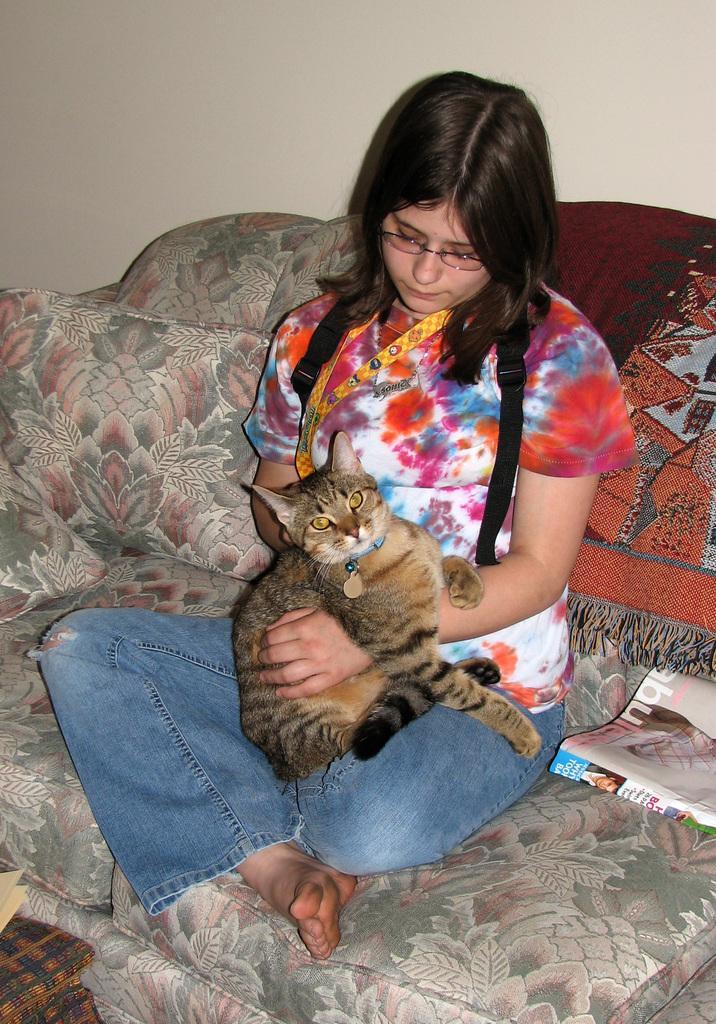Can you describe this image briefly? In this picture i could see a woman holding a cat in her lap with hands, woman is sitting on the sofa and in the back ground i could see a wall. 